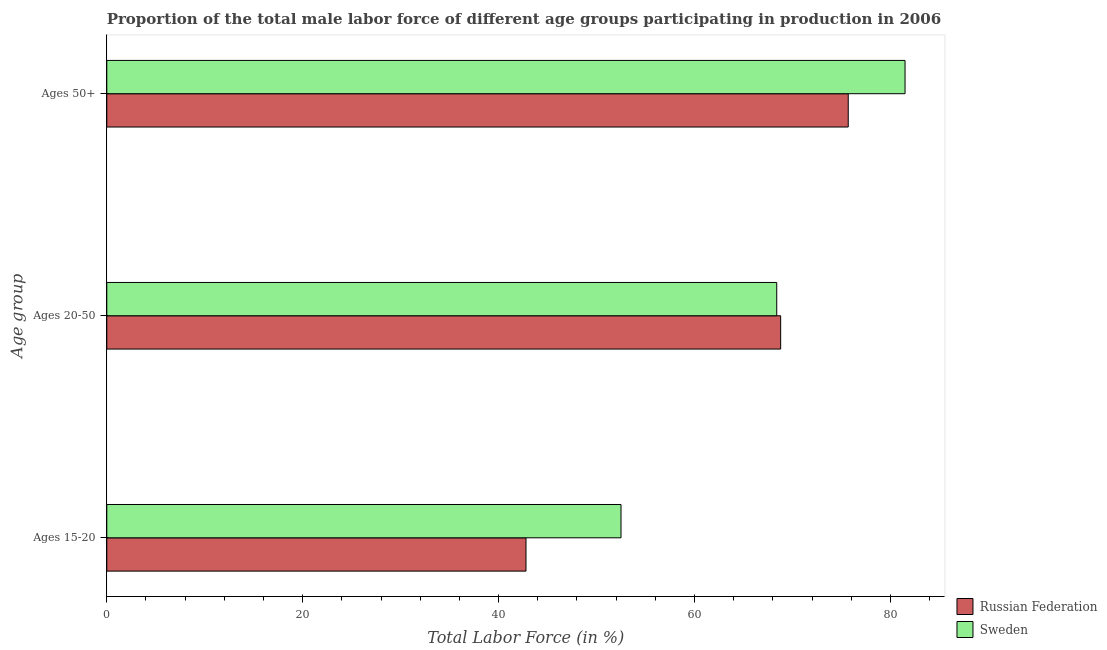How many different coloured bars are there?
Your answer should be compact. 2. Are the number of bars per tick equal to the number of legend labels?
Offer a terse response. Yes. How many bars are there on the 3rd tick from the top?
Make the answer very short. 2. What is the label of the 2nd group of bars from the top?
Your answer should be compact. Ages 20-50. What is the percentage of male labor force above age 50 in Russian Federation?
Your answer should be very brief. 75.7. Across all countries, what is the maximum percentage of male labor force within the age group 20-50?
Your response must be concise. 68.8. Across all countries, what is the minimum percentage of male labor force within the age group 15-20?
Offer a very short reply. 42.8. In which country was the percentage of male labor force above age 50 maximum?
Offer a terse response. Sweden. In which country was the percentage of male labor force above age 50 minimum?
Your response must be concise. Russian Federation. What is the total percentage of male labor force within the age group 20-50 in the graph?
Provide a succinct answer. 137.2. What is the difference between the percentage of male labor force within the age group 15-20 in Sweden and that in Russian Federation?
Your answer should be compact. 9.7. What is the difference between the percentage of male labor force within the age group 20-50 in Russian Federation and the percentage of male labor force above age 50 in Sweden?
Your response must be concise. -12.7. What is the average percentage of male labor force above age 50 per country?
Keep it short and to the point. 78.6. What is the difference between the percentage of male labor force within the age group 15-20 and percentage of male labor force above age 50 in Russian Federation?
Ensure brevity in your answer.  -32.9. In how many countries, is the percentage of male labor force above age 50 greater than 52 %?
Your response must be concise. 2. What is the ratio of the percentage of male labor force above age 50 in Russian Federation to that in Sweden?
Keep it short and to the point. 0.93. Is the percentage of male labor force above age 50 in Sweden less than that in Russian Federation?
Your answer should be very brief. No. What is the difference between the highest and the second highest percentage of male labor force within the age group 20-50?
Your answer should be compact. 0.4. What is the difference between the highest and the lowest percentage of male labor force within the age group 20-50?
Keep it short and to the point. 0.4. Is the sum of the percentage of male labor force within the age group 20-50 in Russian Federation and Sweden greater than the maximum percentage of male labor force within the age group 15-20 across all countries?
Offer a terse response. Yes. What does the 1st bar from the bottom in Ages 20-50 represents?
Provide a succinct answer. Russian Federation. Are the values on the major ticks of X-axis written in scientific E-notation?
Offer a terse response. No. Does the graph contain any zero values?
Offer a very short reply. No. Where does the legend appear in the graph?
Offer a terse response. Bottom right. How many legend labels are there?
Provide a succinct answer. 2. What is the title of the graph?
Provide a succinct answer. Proportion of the total male labor force of different age groups participating in production in 2006. What is the label or title of the X-axis?
Your answer should be compact. Total Labor Force (in %). What is the label or title of the Y-axis?
Offer a very short reply. Age group. What is the Total Labor Force (in %) of Russian Federation in Ages 15-20?
Make the answer very short. 42.8. What is the Total Labor Force (in %) in Sweden in Ages 15-20?
Your answer should be compact. 52.5. What is the Total Labor Force (in %) in Russian Federation in Ages 20-50?
Give a very brief answer. 68.8. What is the Total Labor Force (in %) in Sweden in Ages 20-50?
Offer a terse response. 68.4. What is the Total Labor Force (in %) in Russian Federation in Ages 50+?
Offer a very short reply. 75.7. What is the Total Labor Force (in %) in Sweden in Ages 50+?
Keep it short and to the point. 81.5. Across all Age group, what is the maximum Total Labor Force (in %) in Russian Federation?
Provide a short and direct response. 75.7. Across all Age group, what is the maximum Total Labor Force (in %) in Sweden?
Keep it short and to the point. 81.5. Across all Age group, what is the minimum Total Labor Force (in %) in Russian Federation?
Your answer should be very brief. 42.8. Across all Age group, what is the minimum Total Labor Force (in %) in Sweden?
Offer a terse response. 52.5. What is the total Total Labor Force (in %) in Russian Federation in the graph?
Give a very brief answer. 187.3. What is the total Total Labor Force (in %) in Sweden in the graph?
Offer a very short reply. 202.4. What is the difference between the Total Labor Force (in %) in Russian Federation in Ages 15-20 and that in Ages 20-50?
Your response must be concise. -26. What is the difference between the Total Labor Force (in %) in Sweden in Ages 15-20 and that in Ages 20-50?
Provide a short and direct response. -15.9. What is the difference between the Total Labor Force (in %) in Russian Federation in Ages 15-20 and that in Ages 50+?
Provide a succinct answer. -32.9. What is the difference between the Total Labor Force (in %) of Sweden in Ages 20-50 and that in Ages 50+?
Your response must be concise. -13.1. What is the difference between the Total Labor Force (in %) of Russian Federation in Ages 15-20 and the Total Labor Force (in %) of Sweden in Ages 20-50?
Provide a short and direct response. -25.6. What is the difference between the Total Labor Force (in %) in Russian Federation in Ages 15-20 and the Total Labor Force (in %) in Sweden in Ages 50+?
Provide a short and direct response. -38.7. What is the average Total Labor Force (in %) in Russian Federation per Age group?
Ensure brevity in your answer.  62.43. What is the average Total Labor Force (in %) of Sweden per Age group?
Provide a short and direct response. 67.47. What is the ratio of the Total Labor Force (in %) of Russian Federation in Ages 15-20 to that in Ages 20-50?
Keep it short and to the point. 0.62. What is the ratio of the Total Labor Force (in %) of Sweden in Ages 15-20 to that in Ages 20-50?
Provide a short and direct response. 0.77. What is the ratio of the Total Labor Force (in %) in Russian Federation in Ages 15-20 to that in Ages 50+?
Provide a succinct answer. 0.57. What is the ratio of the Total Labor Force (in %) in Sweden in Ages 15-20 to that in Ages 50+?
Your answer should be very brief. 0.64. What is the ratio of the Total Labor Force (in %) of Russian Federation in Ages 20-50 to that in Ages 50+?
Provide a succinct answer. 0.91. What is the ratio of the Total Labor Force (in %) in Sweden in Ages 20-50 to that in Ages 50+?
Your answer should be very brief. 0.84. What is the difference between the highest and the lowest Total Labor Force (in %) of Russian Federation?
Ensure brevity in your answer.  32.9. What is the difference between the highest and the lowest Total Labor Force (in %) in Sweden?
Ensure brevity in your answer.  29. 